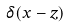<formula> <loc_0><loc_0><loc_500><loc_500>\delta ( x - z )</formula> 